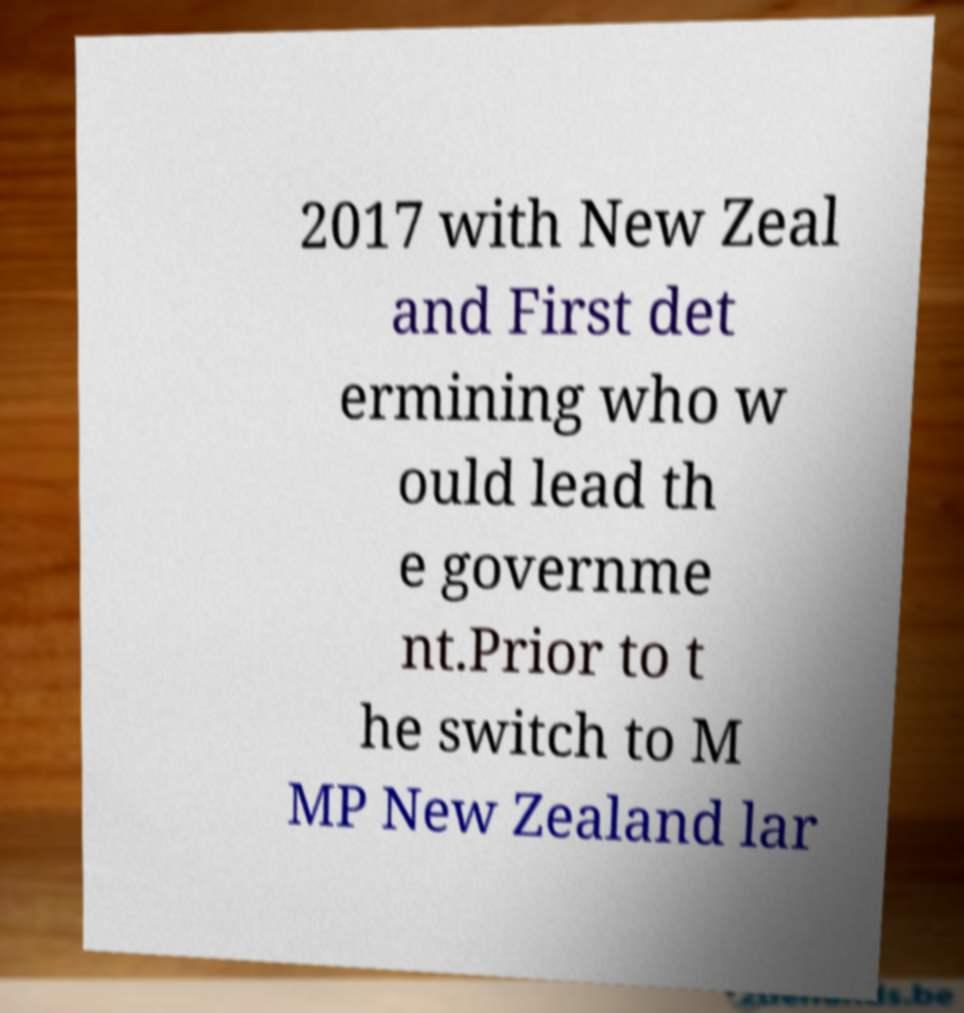Could you extract and type out the text from this image? 2017 with New Zeal and First det ermining who w ould lead th e governme nt.Prior to t he switch to M MP New Zealand lar 